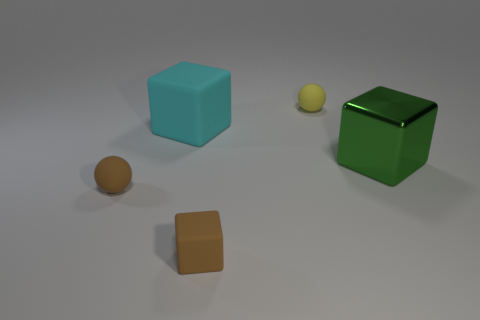Add 4 big gray cylinders. How many objects exist? 9 Subtract all spheres. How many objects are left? 3 Subtract 1 brown cubes. How many objects are left? 4 Subtract all big cyan blocks. Subtract all tiny red shiny balls. How many objects are left? 4 Add 2 metallic things. How many metallic things are left? 3 Add 4 small brown rubber things. How many small brown rubber things exist? 6 